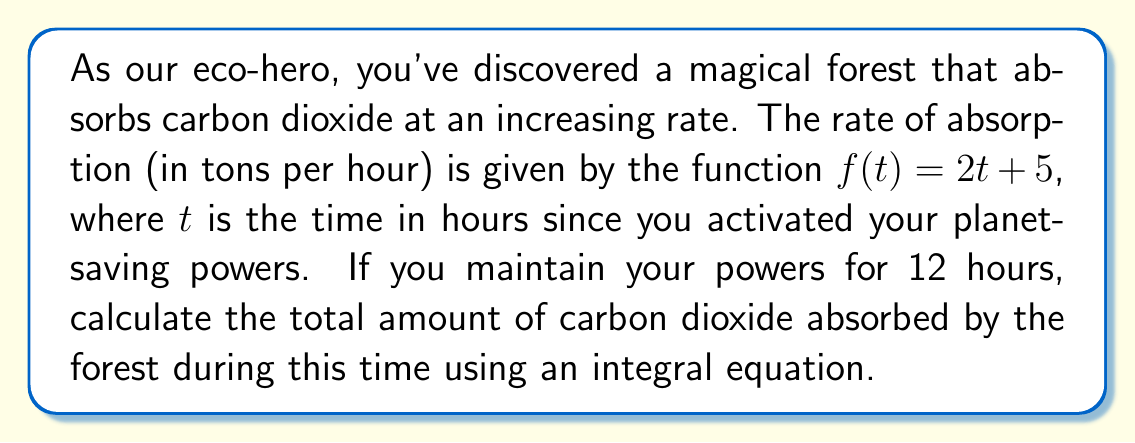Help me with this question. Let's approach this step-by-step:

1) The rate of absorption is given by $f(t) = 2t + 5$ tons per hour.

2) To find the total amount absorbed, we need to integrate this rate over the given time period (0 to 12 hours).

3) We can express this as a definite integral:

   $$\int_0^{12} (2t + 5) dt$$

4) Let's solve this integral:
   
   $$\int_0^{12} (2t + 5) dt = [t^2 + 5t]_0^{12}$$

5) Evaluate the integral:
   
   $$(12^2 + 5(12)) - (0^2 + 5(0))$$
   
   $$= (144 + 60) - 0 = 204$$

6) Therefore, the total amount of carbon dioxide absorbed is 204 tons.
Answer: 204 tons 